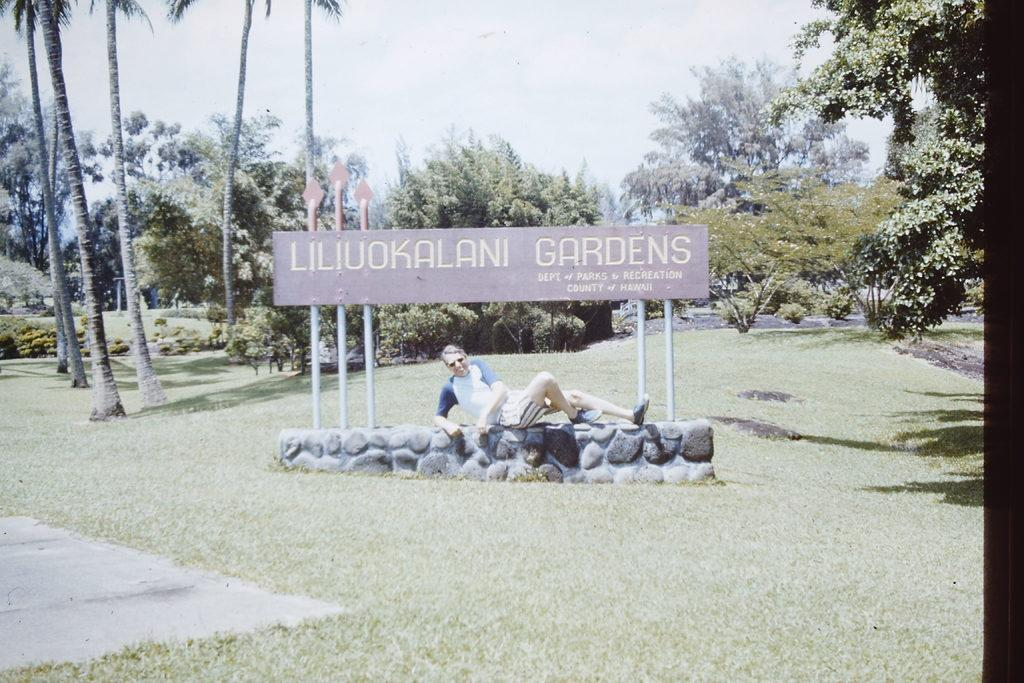What is the main subject of the image? There is a man in the image. Can you describe what the man is wearing? The man is wearing a white t-shirt and shorts. What is the man doing in the image? The man is sitting on a wall. What is on the wall that the man is sitting on? There is a name board on the wall. Where is the wall located? The wall is on a grassland. What can be seen in the background of the image? There are many trees in the background of the image, and the sky is visible. What type of structure is being exchanged between the man and the trees in the image? There is no structure being exchanged between the man and the trees in the image. The man is simply sitting on a wall, and the trees are in the background. 